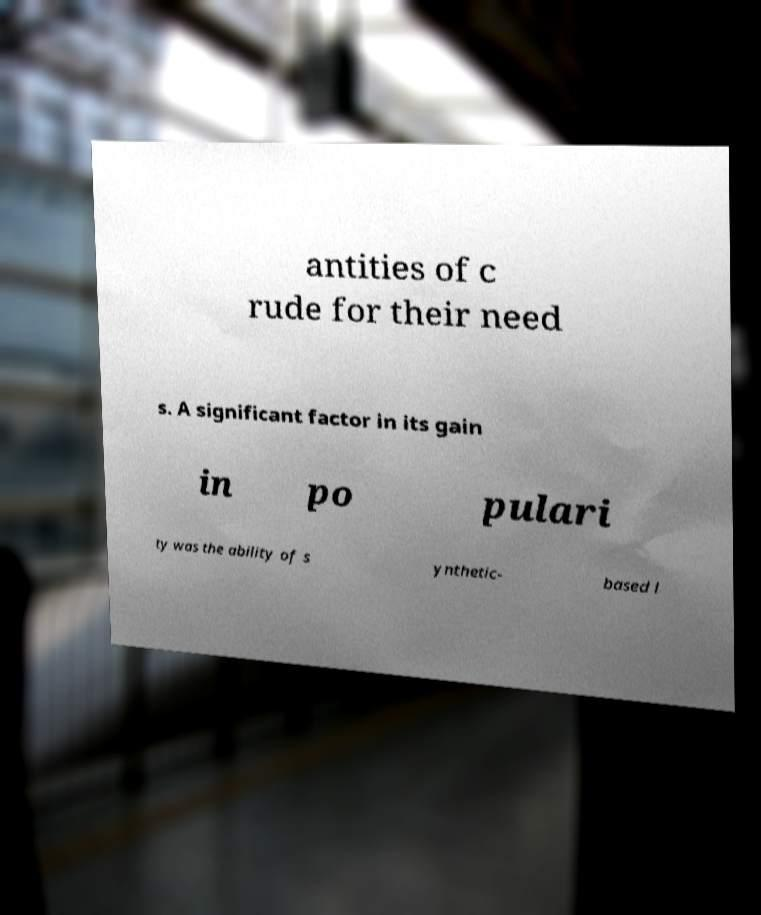Can you read and provide the text displayed in the image?This photo seems to have some interesting text. Can you extract and type it out for me? antities of c rude for their need s. A significant factor in its gain in po pulari ty was the ability of s ynthetic- based l 